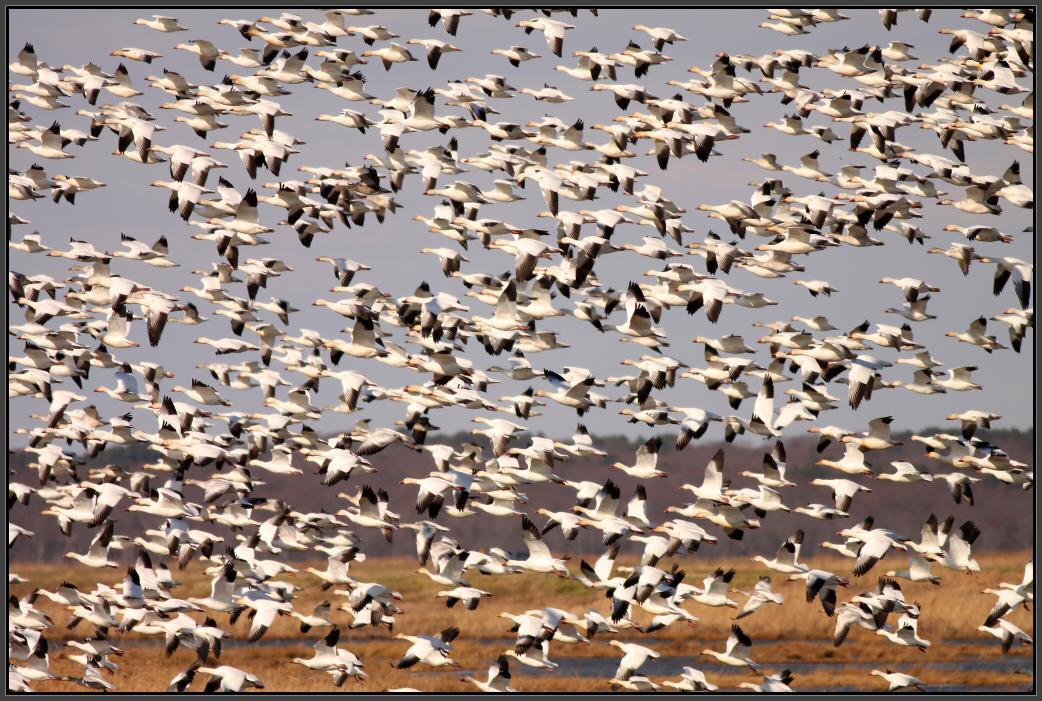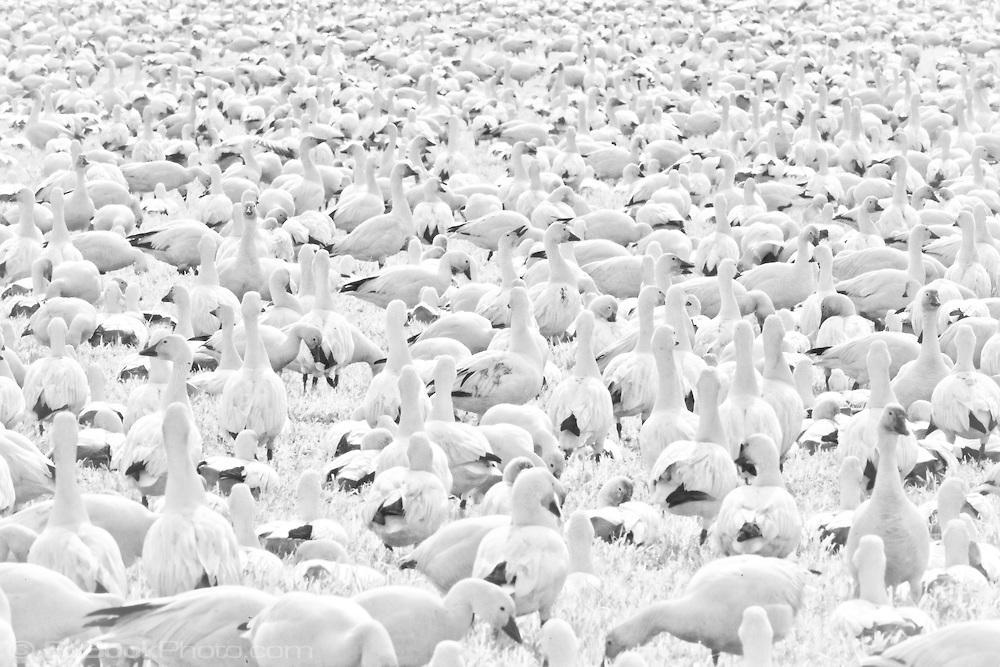The first image is the image on the left, the second image is the image on the right. For the images displayed, is the sentence "One image features multiple ducks on a country road, and the other image shows a mass of white ducks that are not in flight." factually correct? Answer yes or no. No. The first image is the image on the left, the second image is the image on the right. Given the left and right images, does the statement "Geese are waddling on a road in both images." hold true? Answer yes or no. No. 